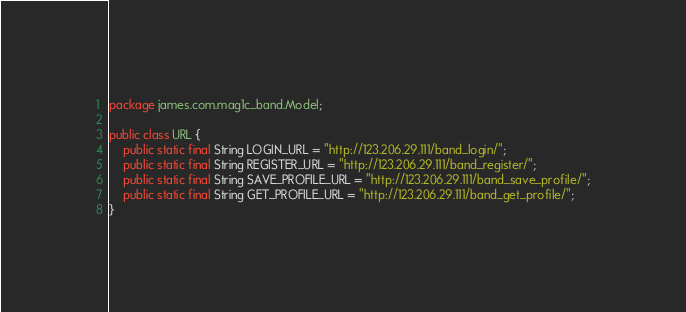<code> <loc_0><loc_0><loc_500><loc_500><_Java_>package james.com.mag1c_band.Model;

public class URL {
    public static final String LOGIN_URL = "http://123.206.29.111/band_login/";
    public static final String REGISTER_URL = "http://123.206.29.111/band_register/";
    public static final String SAVE_PROFILE_URL = "http://123.206.29.111/band_save_profile/";
    public static final String GET_PROFILE_URL = "http://123.206.29.111/band_get_profile/";
}
</code> 